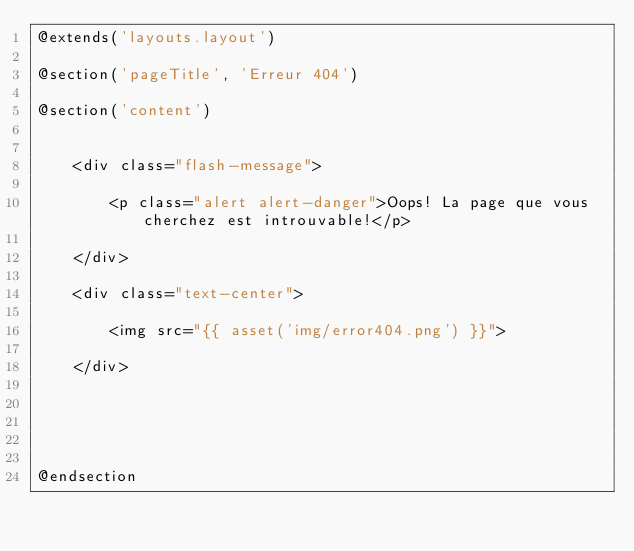<code> <loc_0><loc_0><loc_500><loc_500><_PHP_>@extends('layouts.layout')

@section('pageTitle', 'Erreur 404')

@section('content')


    <div class="flash-message">

        <p class="alert alert-danger">Oops! La page que vous cherchez est introuvable!</p>

    </div>

    <div class="text-center">

        <img src="{{ asset('img/error404.png') }}">

    </div>





@endsection
</code> 